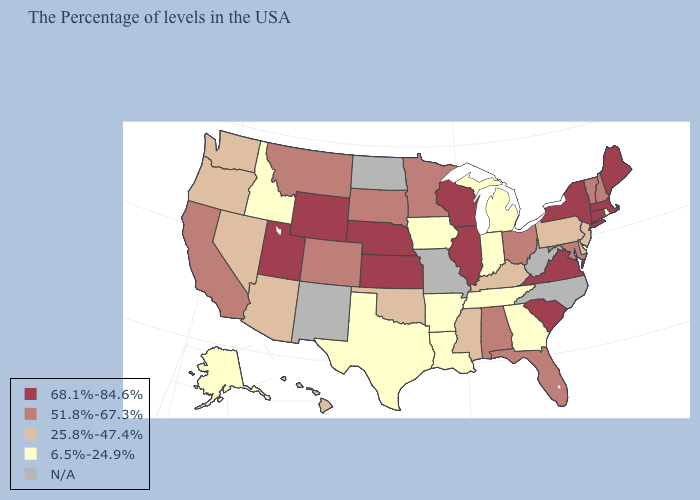Among the states that border Montana , does Wyoming have the lowest value?
Be succinct. No. What is the highest value in states that border New Mexico?
Concise answer only. 68.1%-84.6%. What is the lowest value in the USA?
Quick response, please. 6.5%-24.9%. What is the value of Mississippi?
Quick response, please. 25.8%-47.4%. Name the states that have a value in the range 68.1%-84.6%?
Short answer required. Maine, Massachusetts, Connecticut, New York, Virginia, South Carolina, Wisconsin, Illinois, Kansas, Nebraska, Wyoming, Utah. Does the first symbol in the legend represent the smallest category?
Quick response, please. No. What is the lowest value in the West?
Write a very short answer. 6.5%-24.9%. What is the value of Kansas?
Quick response, please. 68.1%-84.6%. Does Georgia have the lowest value in the USA?
Be succinct. Yes. Name the states that have a value in the range 25.8%-47.4%?
Concise answer only. New Jersey, Delaware, Pennsylvania, Kentucky, Mississippi, Oklahoma, Arizona, Nevada, Washington, Oregon, Hawaii. What is the value of Minnesota?
Give a very brief answer. 51.8%-67.3%. Does Connecticut have the highest value in the Northeast?
Write a very short answer. Yes. Name the states that have a value in the range 51.8%-67.3%?
Keep it brief. New Hampshire, Vermont, Maryland, Ohio, Florida, Alabama, Minnesota, South Dakota, Colorado, Montana, California. Among the states that border Maryland , which have the highest value?
Be succinct. Virginia. Name the states that have a value in the range 68.1%-84.6%?
Quick response, please. Maine, Massachusetts, Connecticut, New York, Virginia, South Carolina, Wisconsin, Illinois, Kansas, Nebraska, Wyoming, Utah. 